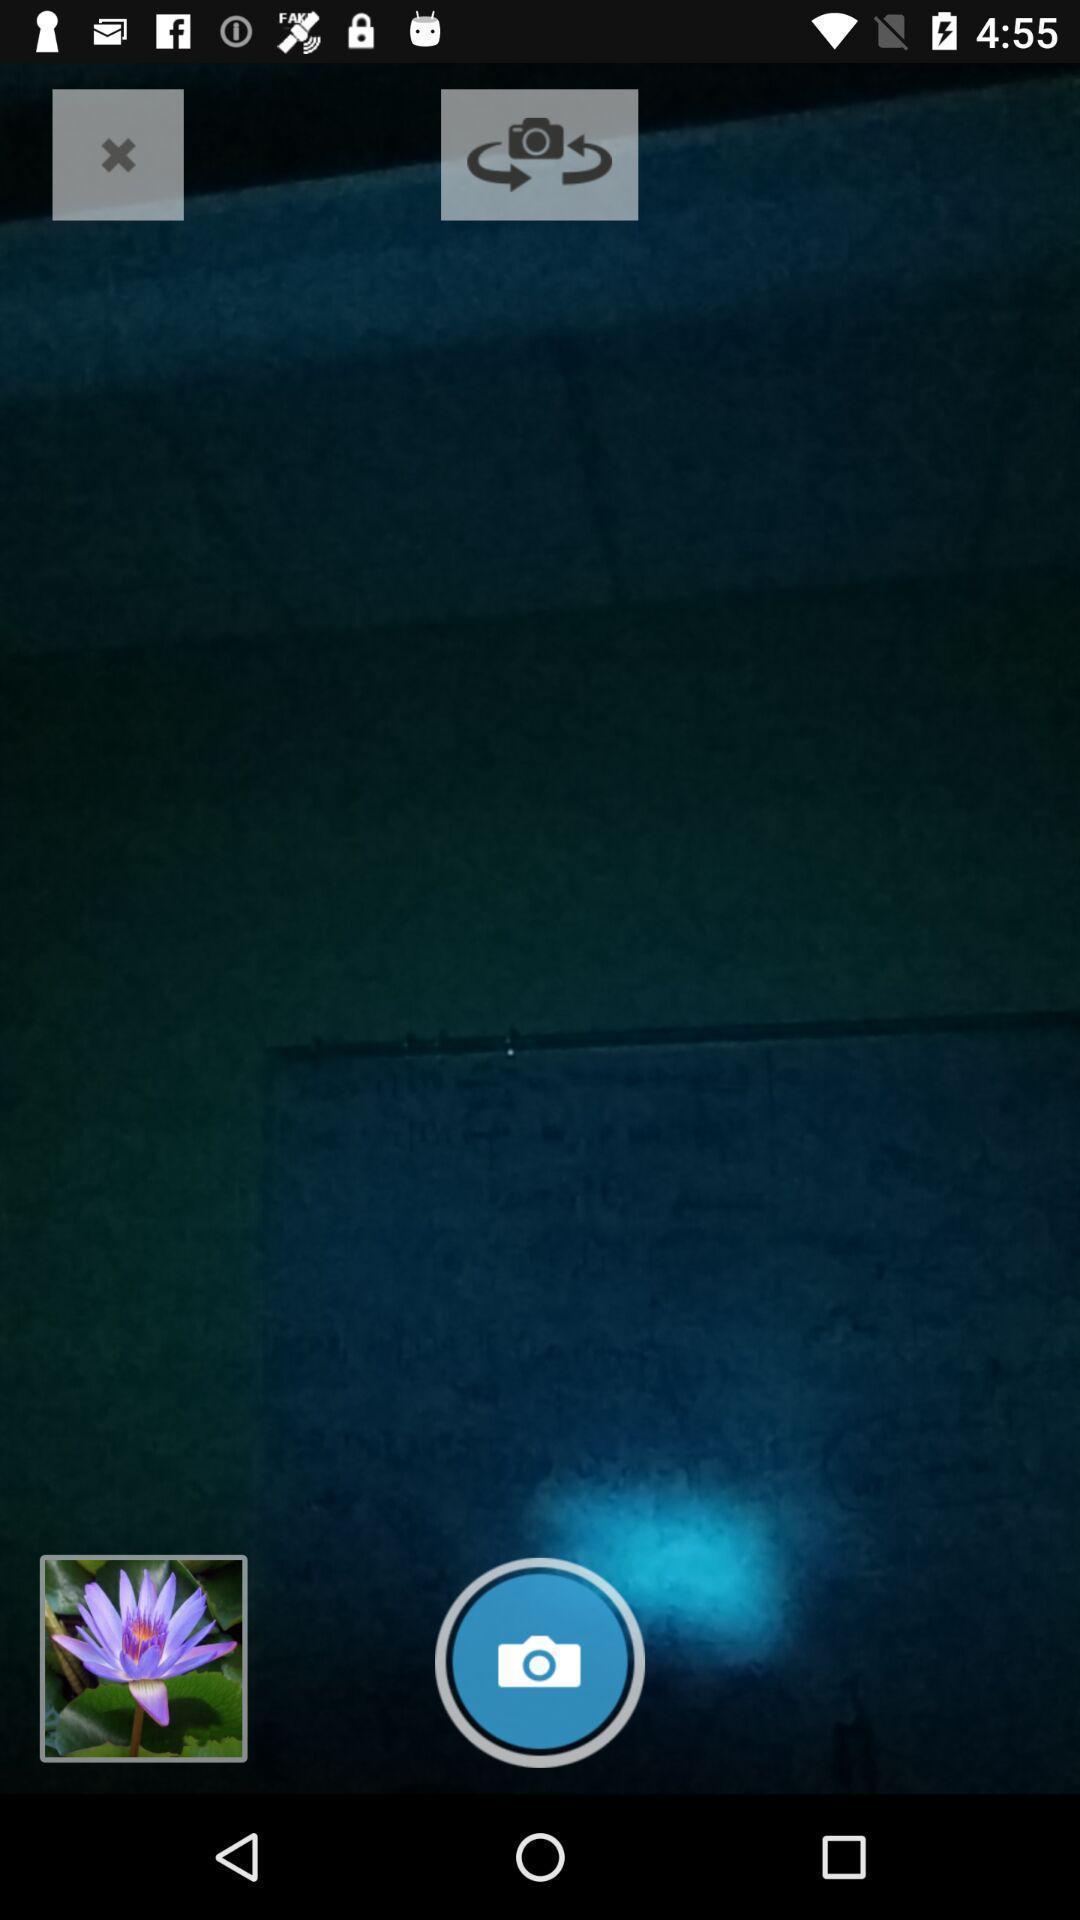Describe this image in words. Screen displaying a camera icon and other control options. 